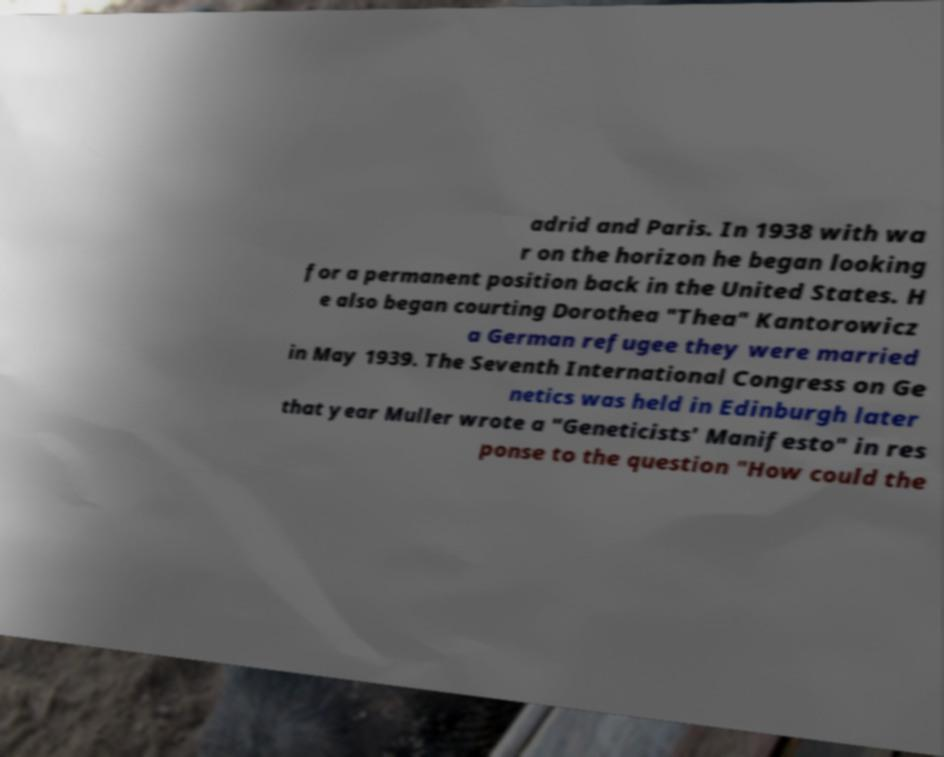What messages or text are displayed in this image? I need them in a readable, typed format. adrid and Paris. In 1938 with wa r on the horizon he began looking for a permanent position back in the United States. H e also began courting Dorothea "Thea" Kantorowicz a German refugee they were married in May 1939. The Seventh International Congress on Ge netics was held in Edinburgh later that year Muller wrote a "Geneticists' Manifesto" in res ponse to the question "How could the 